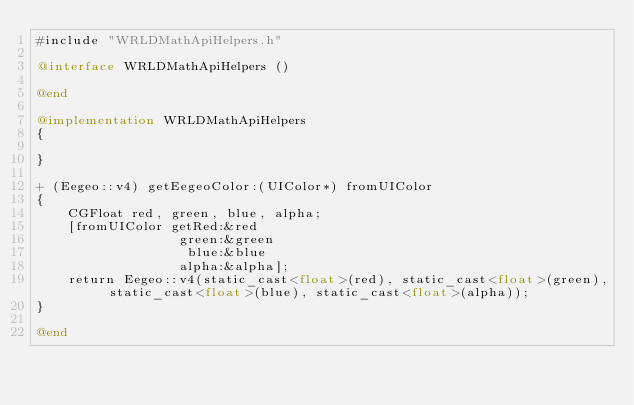Convert code to text. <code><loc_0><loc_0><loc_500><loc_500><_ObjectiveC_>#include "WRLDMathApiHelpers.h"

@interface WRLDMathApiHelpers ()

@end

@implementation WRLDMathApiHelpers
{

}

+ (Eegeo::v4) getEegeoColor:(UIColor*) fromUIColor
{
    CGFloat red, green, blue, alpha;
    [fromUIColor getRed:&red
                  green:&green
                   blue:&blue
                  alpha:&alpha];
    return Eegeo::v4(static_cast<float>(red), static_cast<float>(green), static_cast<float>(blue), static_cast<float>(alpha));
}

@end
</code> 